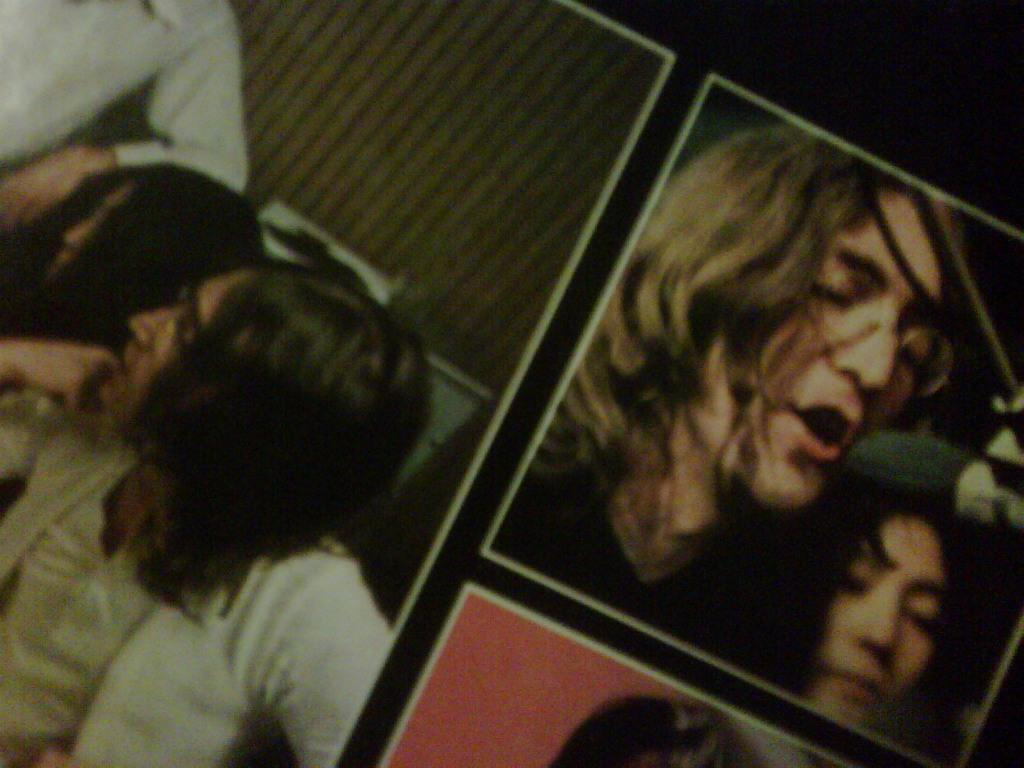What type of image is being described? The image is a collage. Can you identify any subjects in the collage? Yes, there are people in the image. Are there any other elements in the collage besides people? Yes, there are other things in the image. How would you describe the overall appearance of the collage? The background of the image is dark. Where is the key located in the image? There is no key present in the image. Can you tell me how the people in the image are interacting with their selves? There is no indication of self-interaction in the image, as it is a collage of various subjects and elements. 